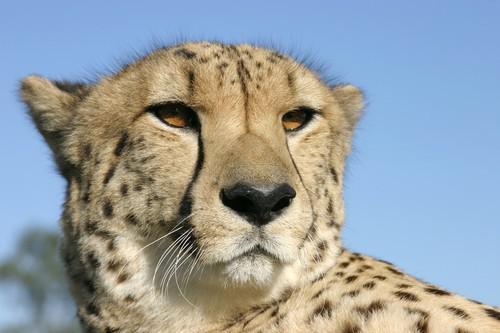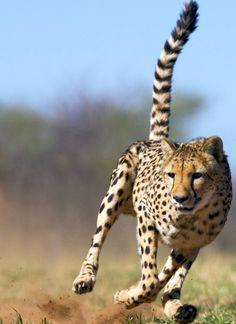The first image is the image on the left, the second image is the image on the right. For the images displayed, is the sentence "There are at most 3 cheetahs in the image pair" factually correct? Answer yes or no. Yes. 